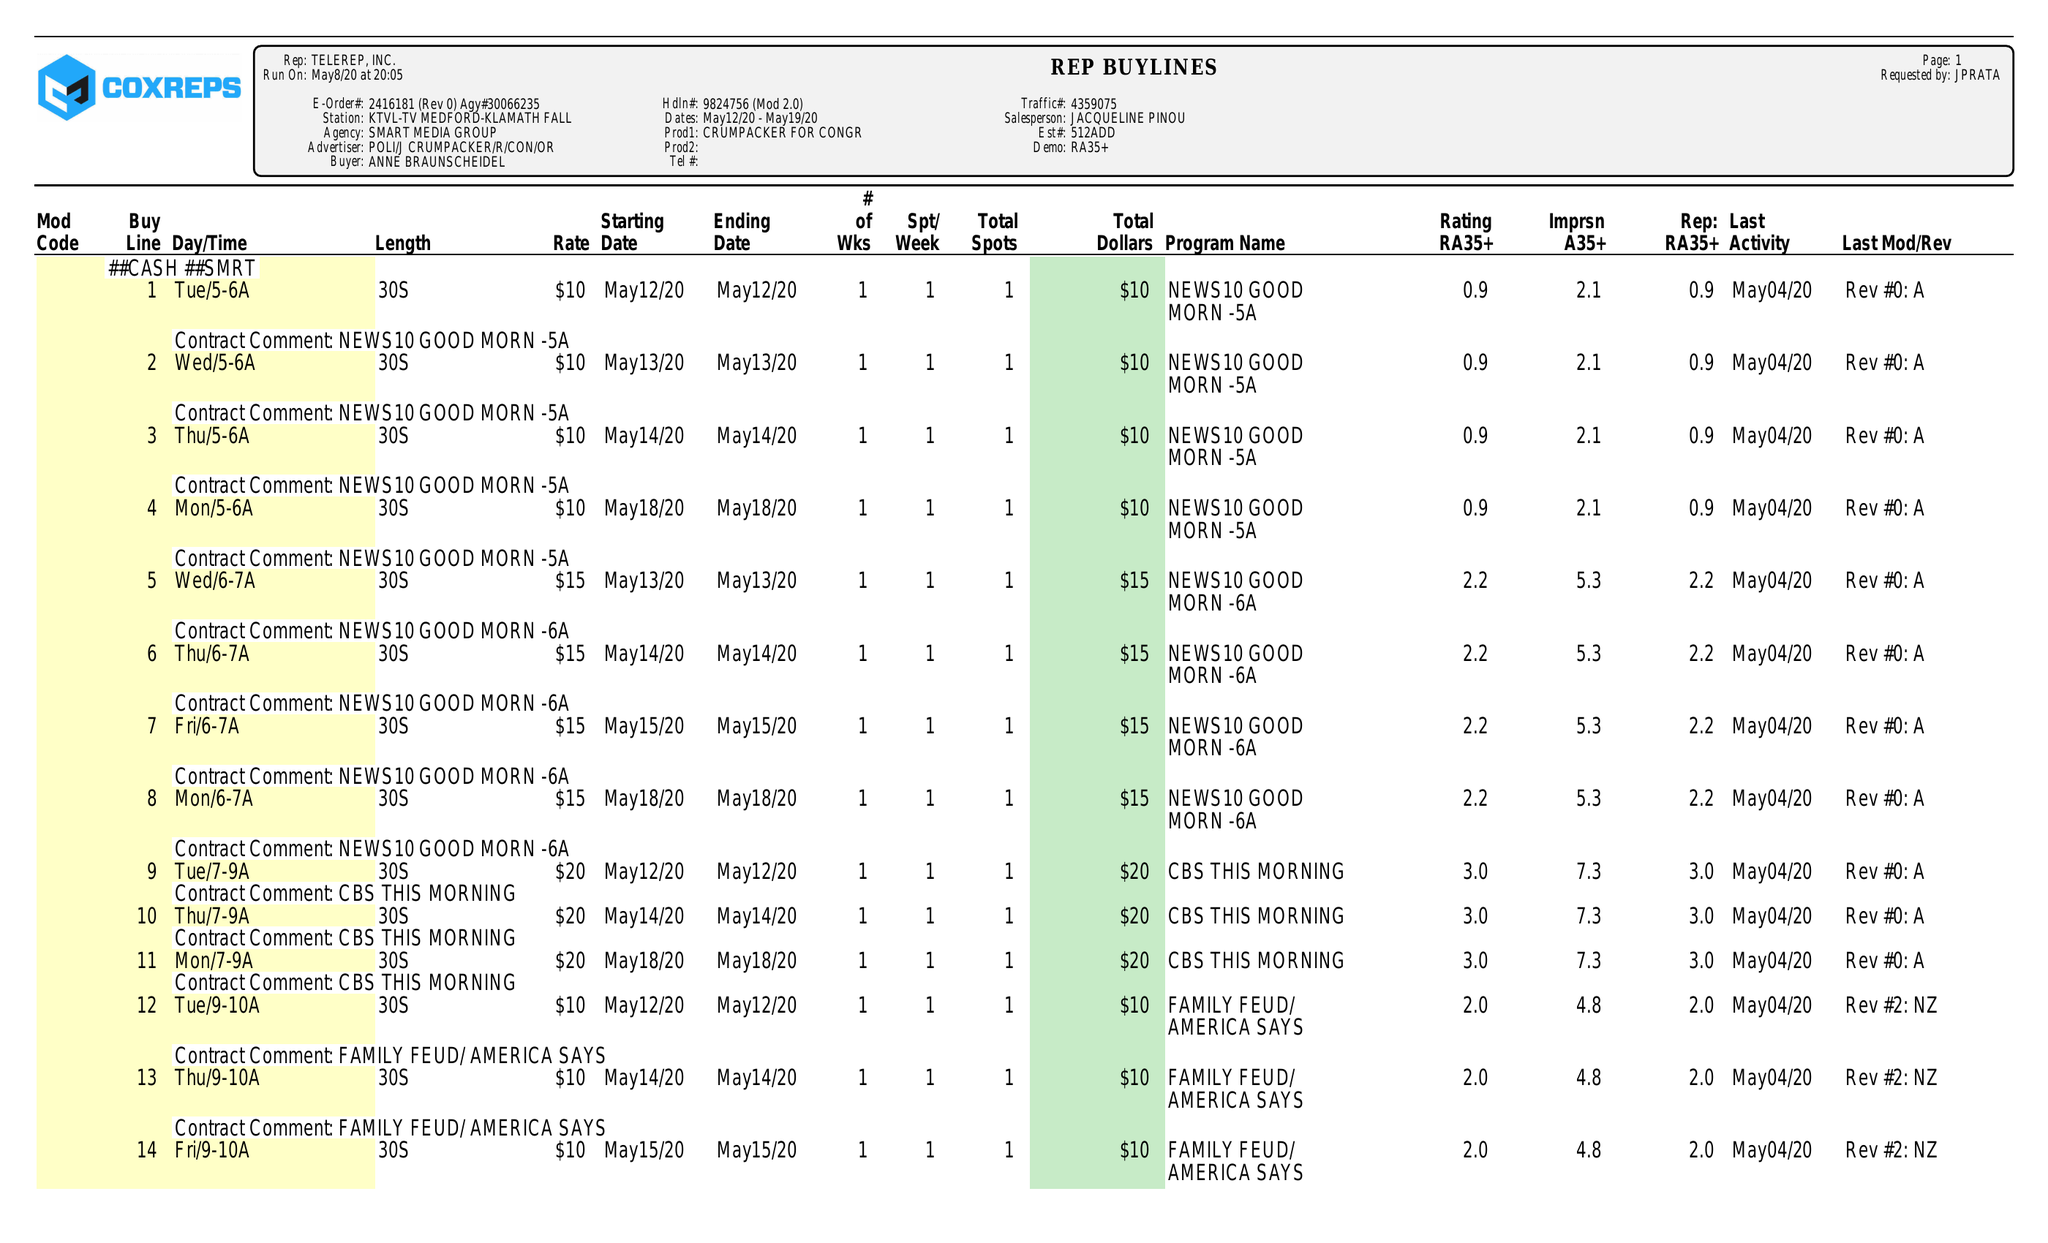What is the value for the gross_amount?
Answer the question using a single word or phrase. 3110.00 